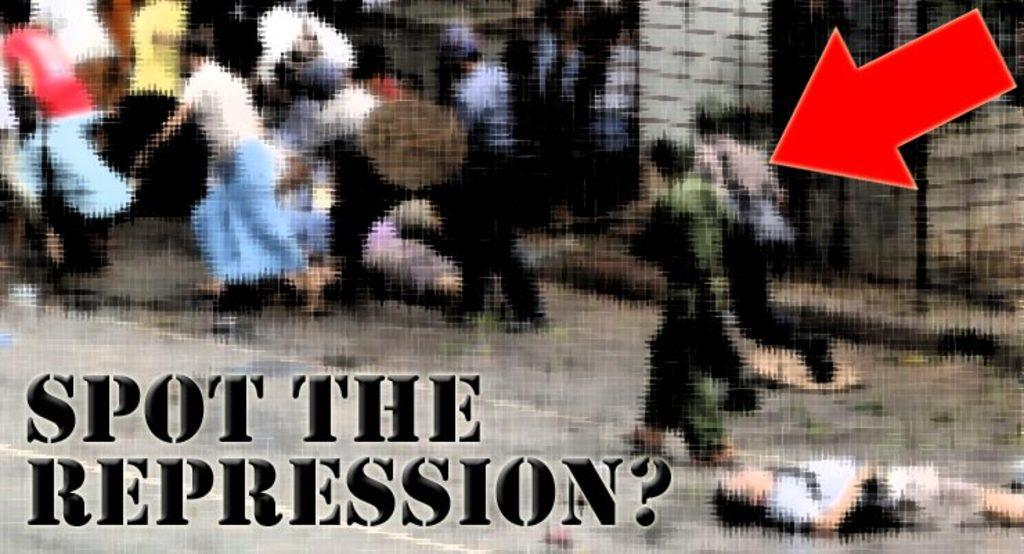What is featured on the poster in the image? There is a poster in the image, and it has an arrow on it. What can be observed about the arrow on the poster? The arrow is in red color. What does the arrow on the poster indicate? The arrow on the poster indicates people. Can you describe the people in the image? There are people standing on the ground in the image. Can you tell me how many beetles are crawling on the poster in the image? There are no beetles present on the poster or in the image. What type of harbor can be seen in the background of the image? There is no harbor visible in the image; it only features a poster with an arrow and people standing on the ground. 